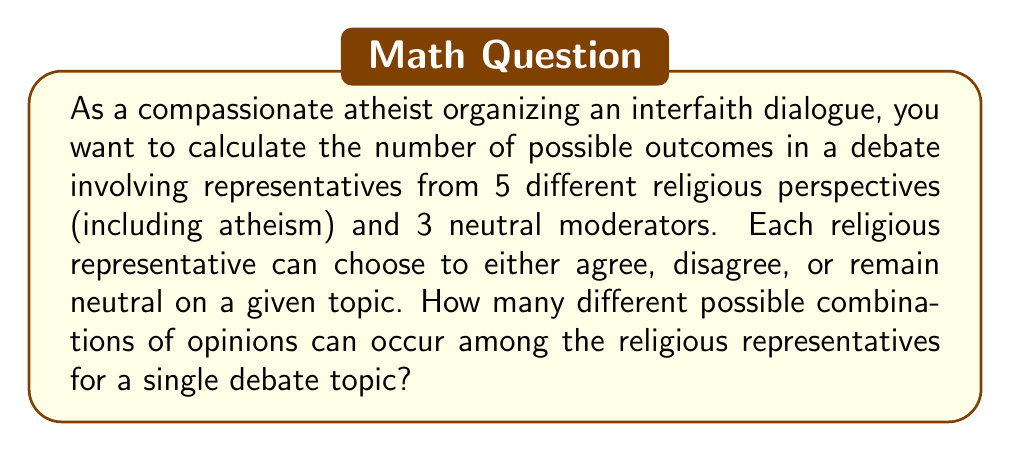Could you help me with this problem? Let's approach this step-by-step:

1) We have 5 religious perspectives represented, including atheism.

2) For each representative, there are 3 possible stances on a given topic:
   - Agree
   - Disagree
   - Remain neutral

3) This scenario can be modeled as a counting problem where we're making 5 independent choices (one for each representative), and each choice has 3 options.

4) This type of problem can be solved using the multiplication principle.

5) The multiplication principle states that if we have $n$ independent events, and each event $i$ has $k_i$ possible outcomes, then the total number of possible outcomes for all events is:

   $$ \prod_{i=1}^n k_i $$

6) In our case, we have 5 independent events (the choice of each representative), and each event has 3 possible outcomes.

7) Therefore, the total number of possible combinations is:

   $$ 3 \times 3 \times 3 \times 3 \times 3 = 3^5 $$

8) Calculate:
   $$ 3^5 = 3 \times 3 \times 3 \times 3 \times 3 = 243 $$

Thus, there are 243 possible combinations of opinions among the religious representatives for a single debate topic.

Note: The neutral moderators don't affect the calculation as they don't contribute to the opinion combinations.
Answer: 243 possible combinations 